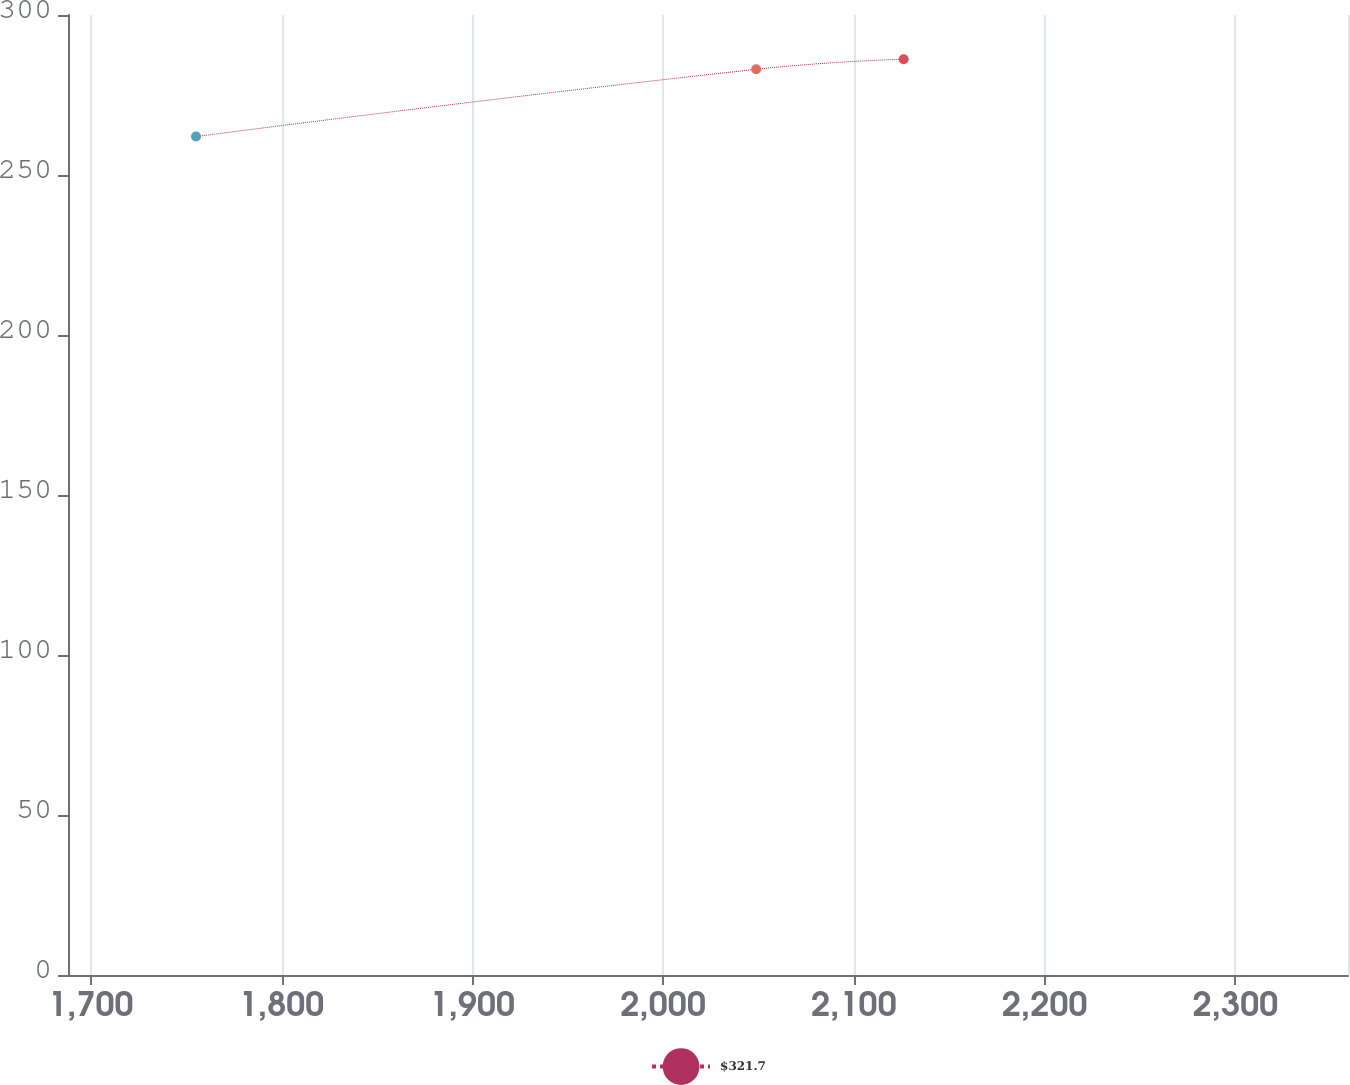<chart> <loc_0><loc_0><loc_500><loc_500><line_chart><ecel><fcel>$321.7<nl><fcel>1755.17<fcel>262.01<nl><fcel>2048.79<fcel>283.03<nl><fcel>2126.09<fcel>286.19<nl><fcel>2426.11<fcel>280.61<nl></chart> 